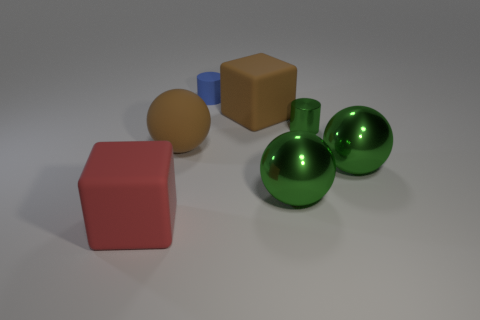There is a blue object on the right side of the red cube; does it have the same shape as the large green shiny object to the left of the small shiny cylinder?
Your answer should be very brief. No. The big rubber block behind the thing to the left of the large brown matte thing that is to the left of the small blue thing is what color?
Your answer should be compact. Brown. What number of other things are the same color as the metallic cylinder?
Provide a succinct answer. 2. Are there fewer red matte blocks than big blue metallic spheres?
Your response must be concise. No. What is the color of the big matte thing that is to the left of the blue rubber cylinder and on the right side of the big red rubber block?
Make the answer very short. Brown. What material is the other small thing that is the same shape as the small matte object?
Give a very brief answer. Metal. Is the number of large red matte blocks greater than the number of tiny purple matte cylinders?
Give a very brief answer. Yes. There is a rubber object that is in front of the brown cube and on the right side of the big red cube; what is its size?
Offer a terse response. Large. There is a blue rubber object; what shape is it?
Provide a short and direct response. Cylinder. How many blue rubber things have the same shape as the red thing?
Your answer should be compact. 0. 